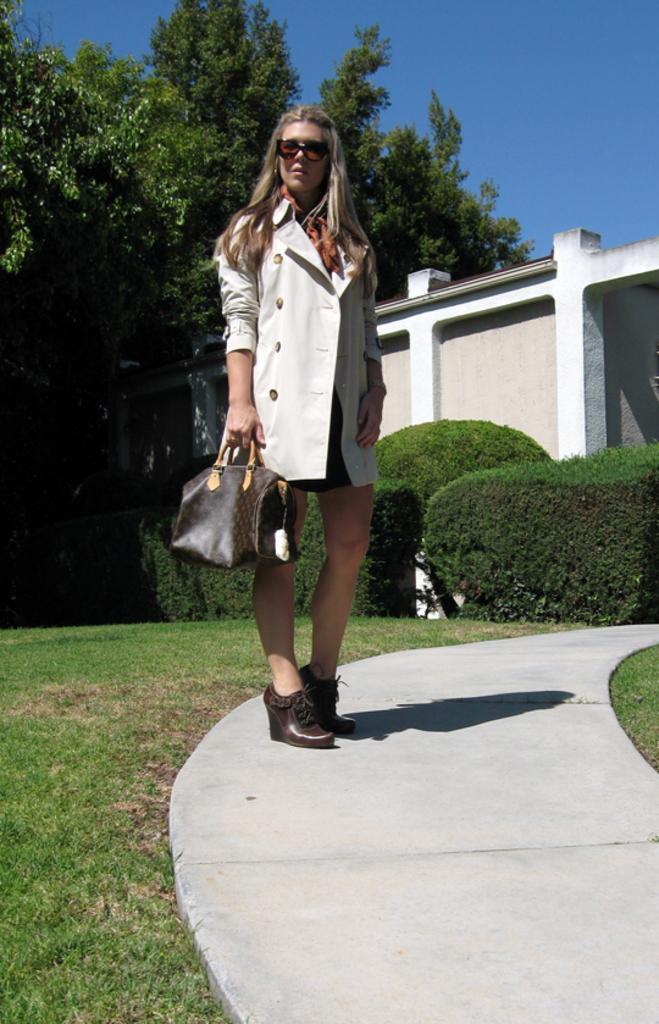Can you describe this image briefly? A lady wearing a white jacket is standing she is carrying a bag. In the background there is a building and trees. 